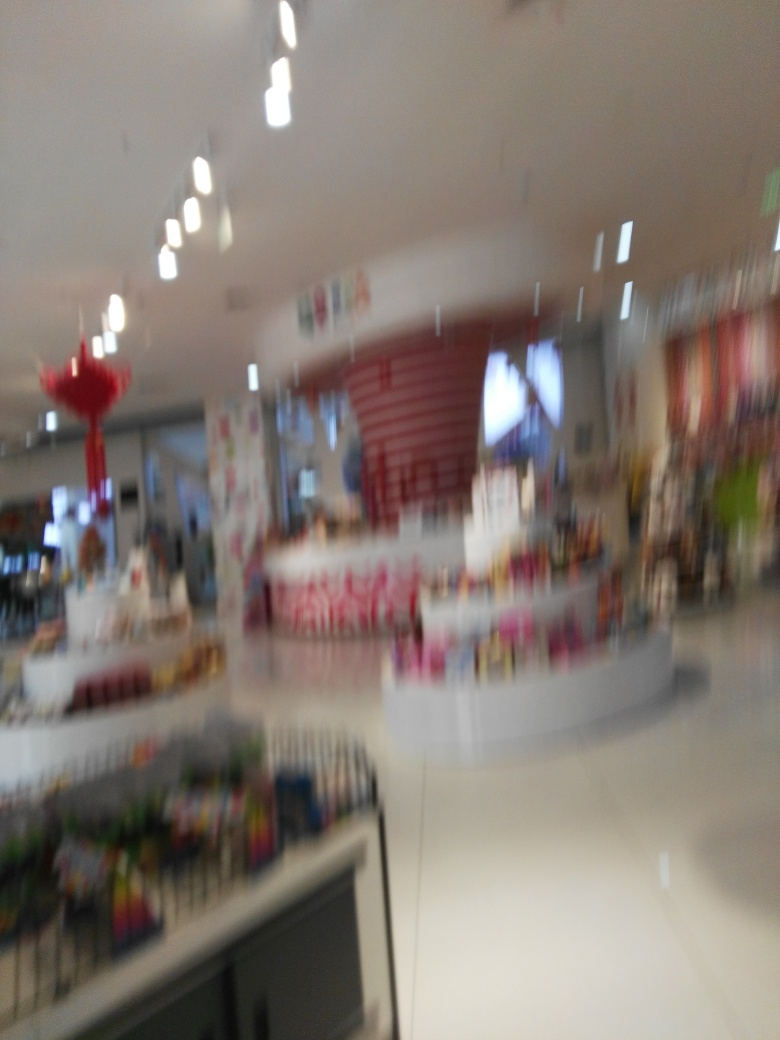How would you describe the outline and details in this photograph? The photograph is out of focus, resulting in blurred outlines and a lack of sharpness that prevents clear identification of specific details. It appears to capture an indoor scene, possibly a retail environment, where lighting fixtures are visible on the ceiling and displays with various items can be vaguely made out. The blurriness may be due to camera movement or an incorrect focus setting when the picture was taken. 